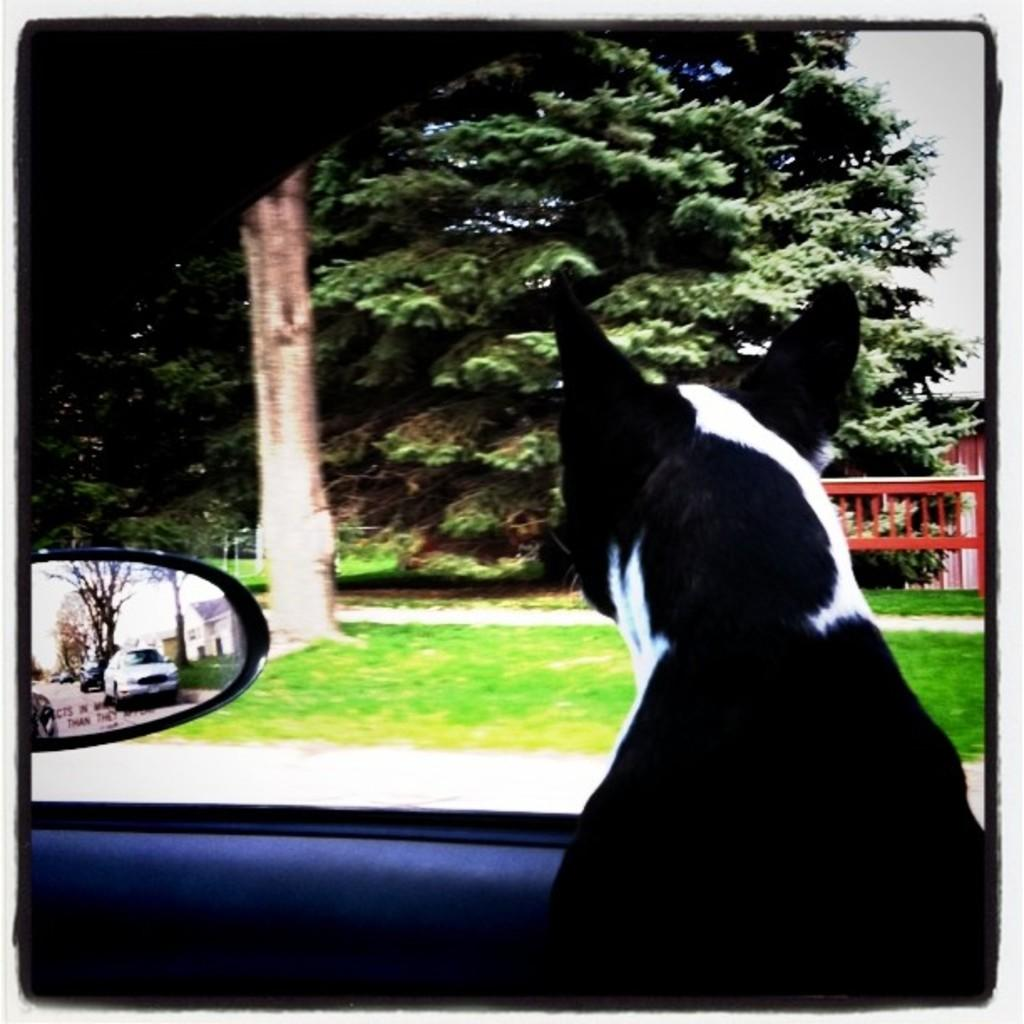What animal can be seen inside the vehicle in the image? There is a dog sitting inside a vehicle in the image. What object is present in the image that allows for reflection? There is a mirror in the image. What does the mirror reflect in the image? The mirror reflects vehicles and a bare tree in the image. What type of vegetation is visible in the distance? There is a tree in the distance in the image. What type of ground surface is visible in the image? There is grass visible in the image. What type of unit is the dog wearing in the image? There is no unit visible in the image, and the dog is not wearing any clothing or accessories. 